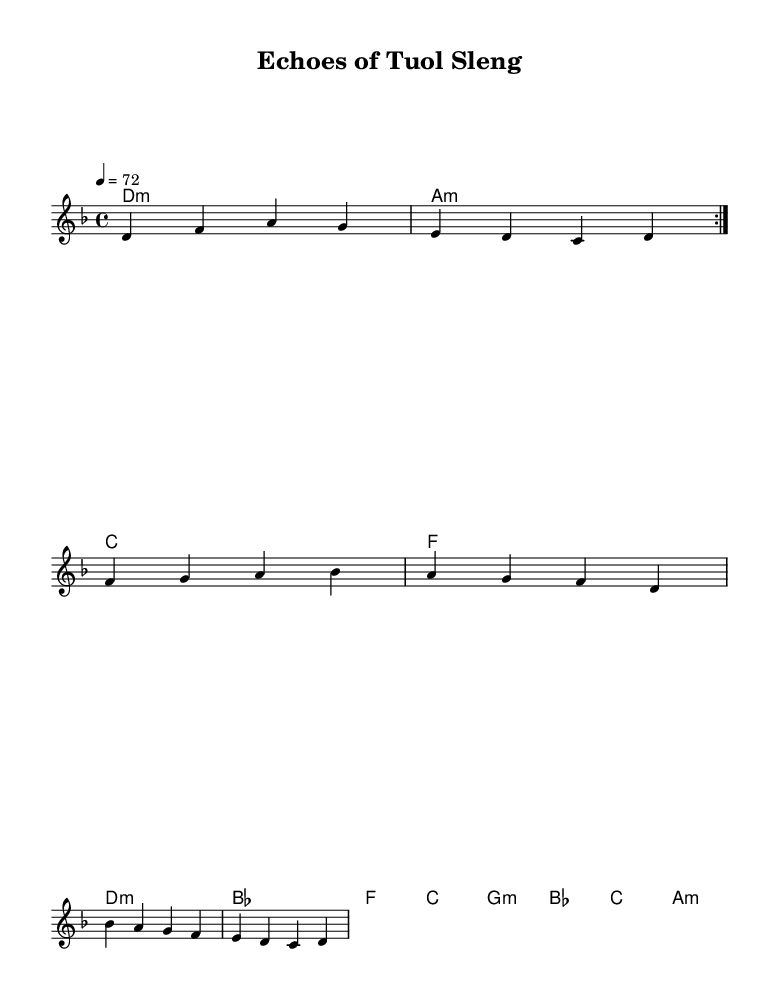What is the key signature of this music? The key signature is D minor, which is indicated by one flat (B flat) and suggests a somber tone fitting for the introspective theme.
Answer: D minor What is the time signature of this music? The time signature is 4/4, indicating four beats per measure, commonly used in folk-rock to create a stable rhythmic structure.
Answer: 4/4 What is the tempo marking of this music? The tempo is marked at 72 beats per minute, which provides a moderate pace suitable for reflective music.
Answer: 72 How many measures are in the verse? There are four measures in the verse, as indicated by the sequence of notes and rests before the chorus begins.
Answer: 4 What is the overall structure of the piece? The music follows a verse-chorus-bridge format, typical in rock music, where thematic ideas are developed and contrasted.
Answer: Verse-Chorus-Bridge What is the first lyric of the chorus? The first lyric of the chorus is "Echoes of Tuol Sleng," directly emphasizing the theme of memory and trauma associated with the Khmer Rouge.
Answer: Echoes of Tuol Sleng How many different harmonies are used in the song? There are eight distinct harmonies used throughout the piece, creating emotional depth and resonance typical in folk-rock compositions.
Answer: 8 